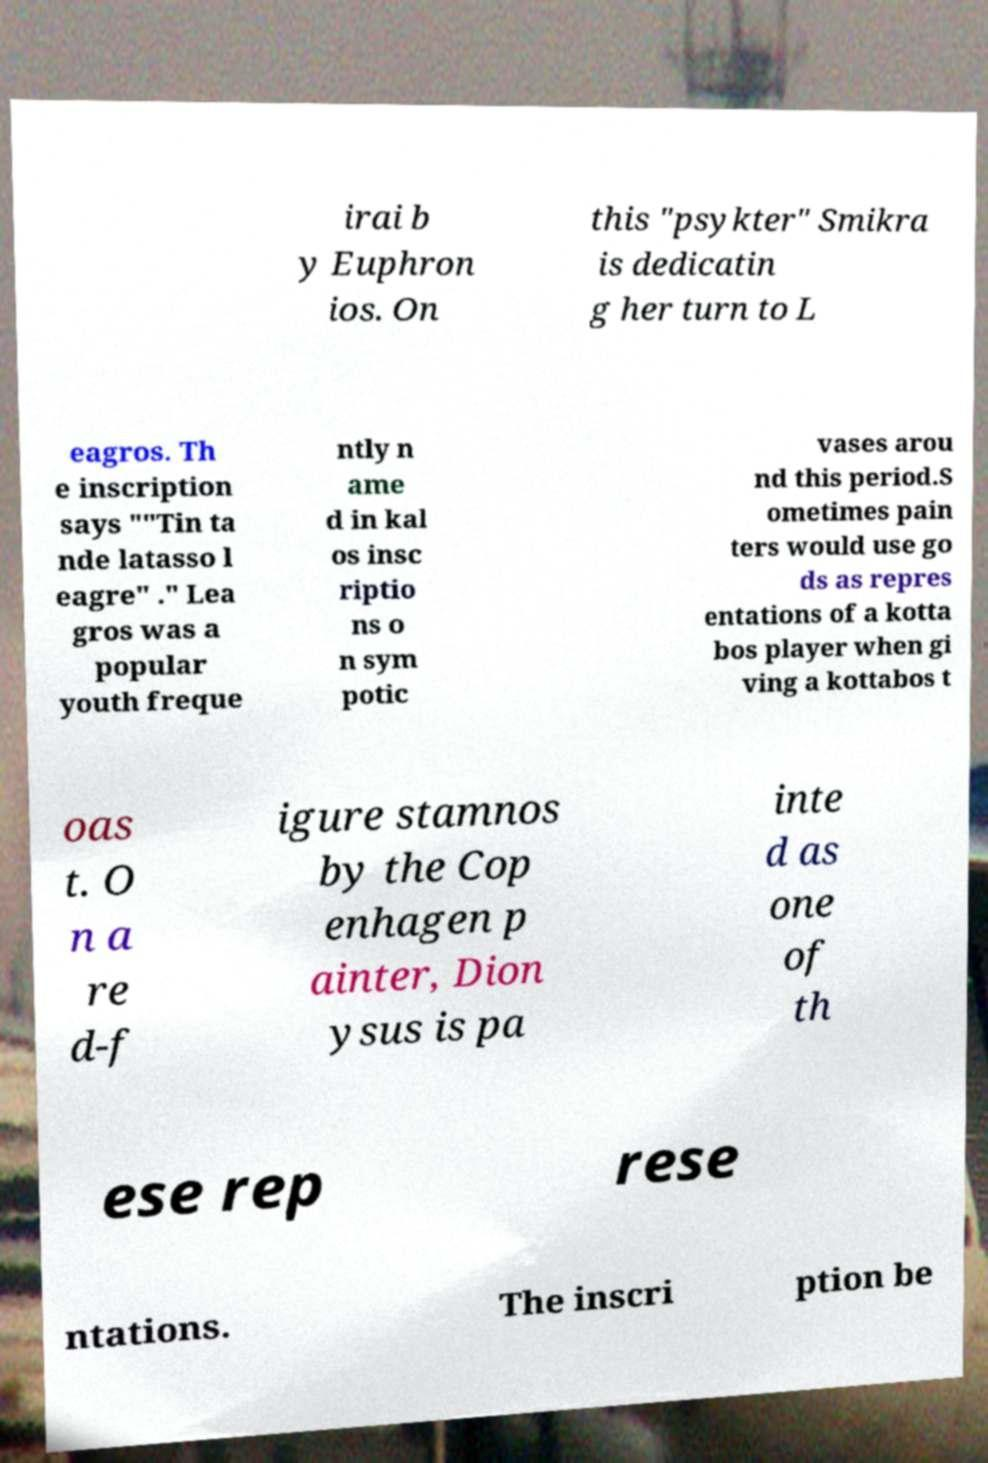Could you extract and type out the text from this image? irai b y Euphron ios. On this "psykter" Smikra is dedicatin g her turn to L eagros. Th e inscription says ""Tin ta nde latasso l eagre" ." Lea gros was a popular youth freque ntly n ame d in kal os insc riptio ns o n sym potic vases arou nd this period.S ometimes pain ters would use go ds as repres entations of a kotta bos player when gi ving a kottabos t oas t. O n a re d-f igure stamnos by the Cop enhagen p ainter, Dion ysus is pa inte d as one of th ese rep rese ntations. The inscri ption be 